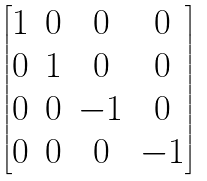Convert formula to latex. <formula><loc_0><loc_0><loc_500><loc_500>\begin{bmatrix} 1 & 0 & 0 & 0 \\ 0 & 1 & 0 & 0 \\ 0 & 0 & - 1 & 0 \\ 0 & 0 & 0 & - 1 \\ \end{bmatrix}</formula> 